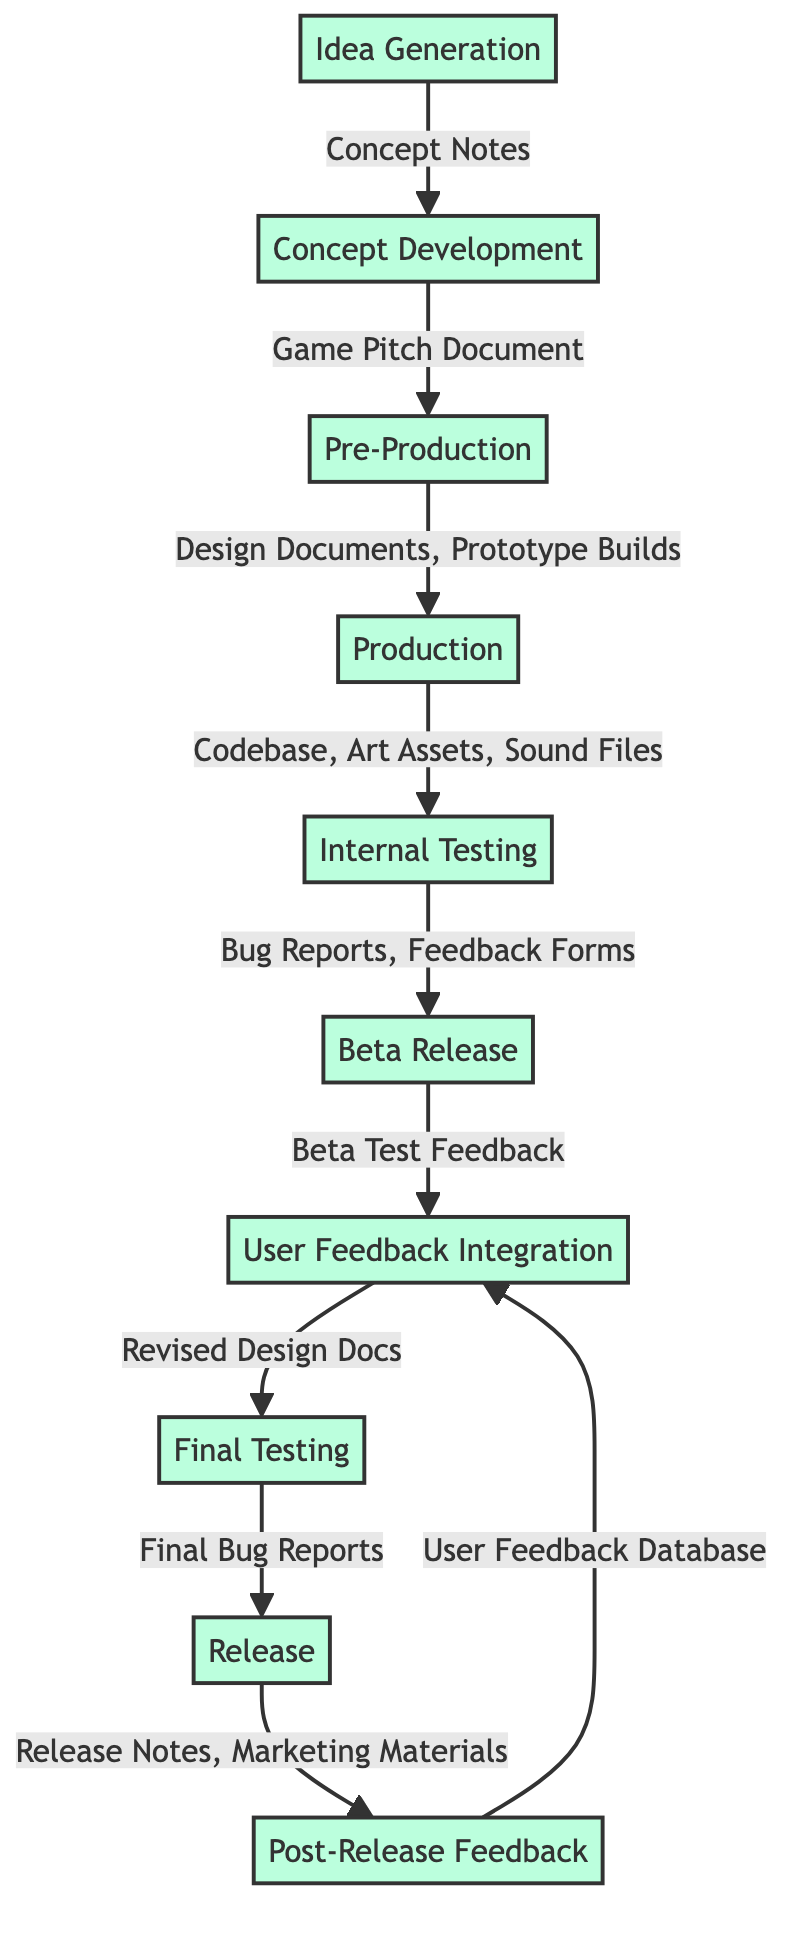What is the first step in the development process? The first step in the development process is the "Idea Generation." This is the initial phase where brainstorming occurs to establish the core concept of the humorous mobile game.
Answer: Idea Generation How many data stores are there in the diagram? By reviewing the diagram, we count the distinct data stores associated with each process. They are: Concept Notes, Game Pitch Document, Design Documents, Prototype Builds, Codebase, Art Assets, Sound Files, Bug Reports, Feedback Forms, Beta Test Feedback, Revised Design Docs, Final Bug Reports, Release Notes, Marketing Materials, and User Feedback Database. This totals to 14 data stores.
Answer: 14 Which process follows "Beta Release"? In the flow of the diagram, the process that comes after "Beta Release" is "User Feedback Integration." This indicates that feedback from testers is taken into account following the beta version release.
Answer: User Feedback Integration What do the final user feedbacks get stored in? The final user feedbacks are stored in the "User Feedback Database." This indicates that all post-launch user reviews and feedback are consolidated here for analysis.
Answer: User Feedback Database Which teams are involved in "Final Testing"? According to the diagram, the "Final Testing" process is handled solely by the "Quality Assurance Team." This team is responsible for conducting quality checks before the official release.
Answer: Quality Assurance Team How many processes precede the "Release" step? By tracing through the flowchart, we can identify the processes leading up to "Release." They are "Idea Generation," "Concept Development," "Pre-Production," "Production," "Internal Testing," "Beta Release," and "User Feedback Integration." Counting these processes gives us seven that precede the release step.
Answer: 7 What does "Production" produce? The "Production" process results in three major outputs: "Codebase," "Art Assets," and "Sound Files." These outputs are critical components for the game's full-scale development.
Answer: Codebase, Art Assets, Sound Files What is the outcome of "User Feedback Integration"? The outcome of "User Feedback Integration" leads to the creation of "Revised Design Docs." This signifies that changes based on user feedback are documented for further iterations of gameplay development.
Answer: Revised Design Docs Which processes are managed by the Development Team? The Development Team is responsible for "Pre-Production," "Production," and "User Feedback Integration" processes as indicated in the diagram. This involves various elements of the game's creation and refining based on feedback.
Answer: Pre-Production, Production, User Feedback Integration 